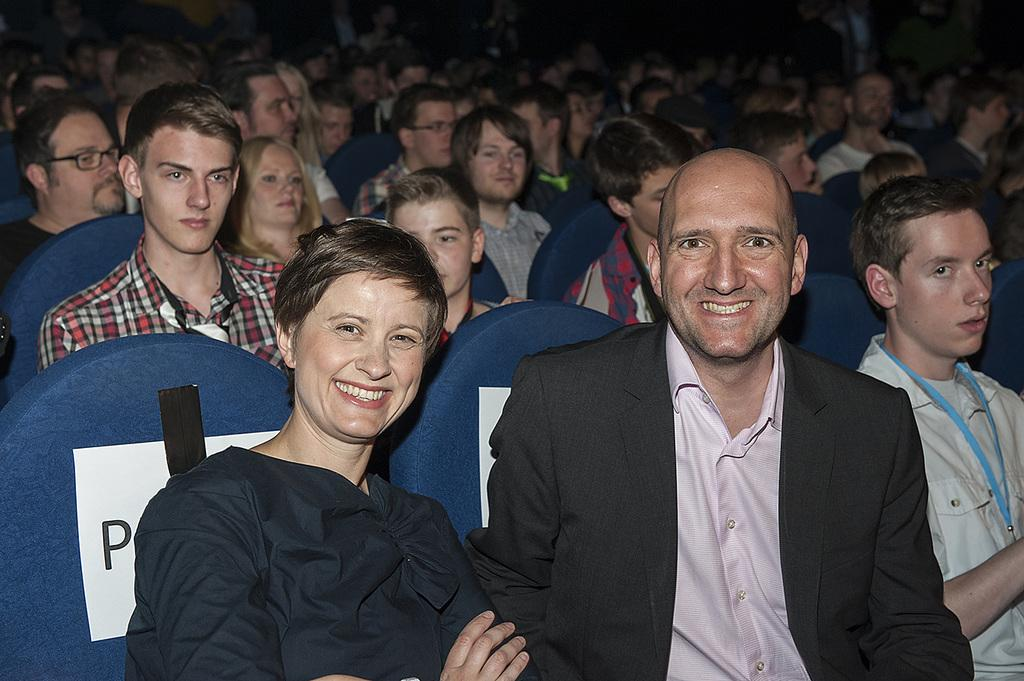What are the people in the image doing? The persons in the image are sitting. What color are the chairs they are sitting on? The chairs they are sitting on are blue. What type of nut can be seen smashing the frame in the image? There is no nut or frame present in the image. 